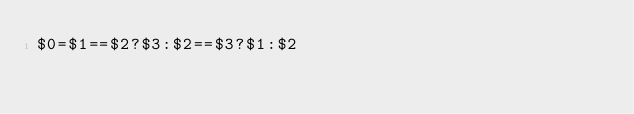Convert code to text. <code><loc_0><loc_0><loc_500><loc_500><_Awk_>$0=$1==$2?$3:$2==$3?$1:$2</code> 